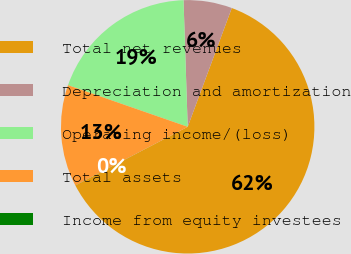<chart> <loc_0><loc_0><loc_500><loc_500><pie_chart><fcel>Total net revenues<fcel>Depreciation and amortization<fcel>Operating income/(loss)<fcel>Total assets<fcel>Income from equity investees<nl><fcel>61.68%<fcel>6.18%<fcel>19.15%<fcel>12.98%<fcel>0.01%<nl></chart> 